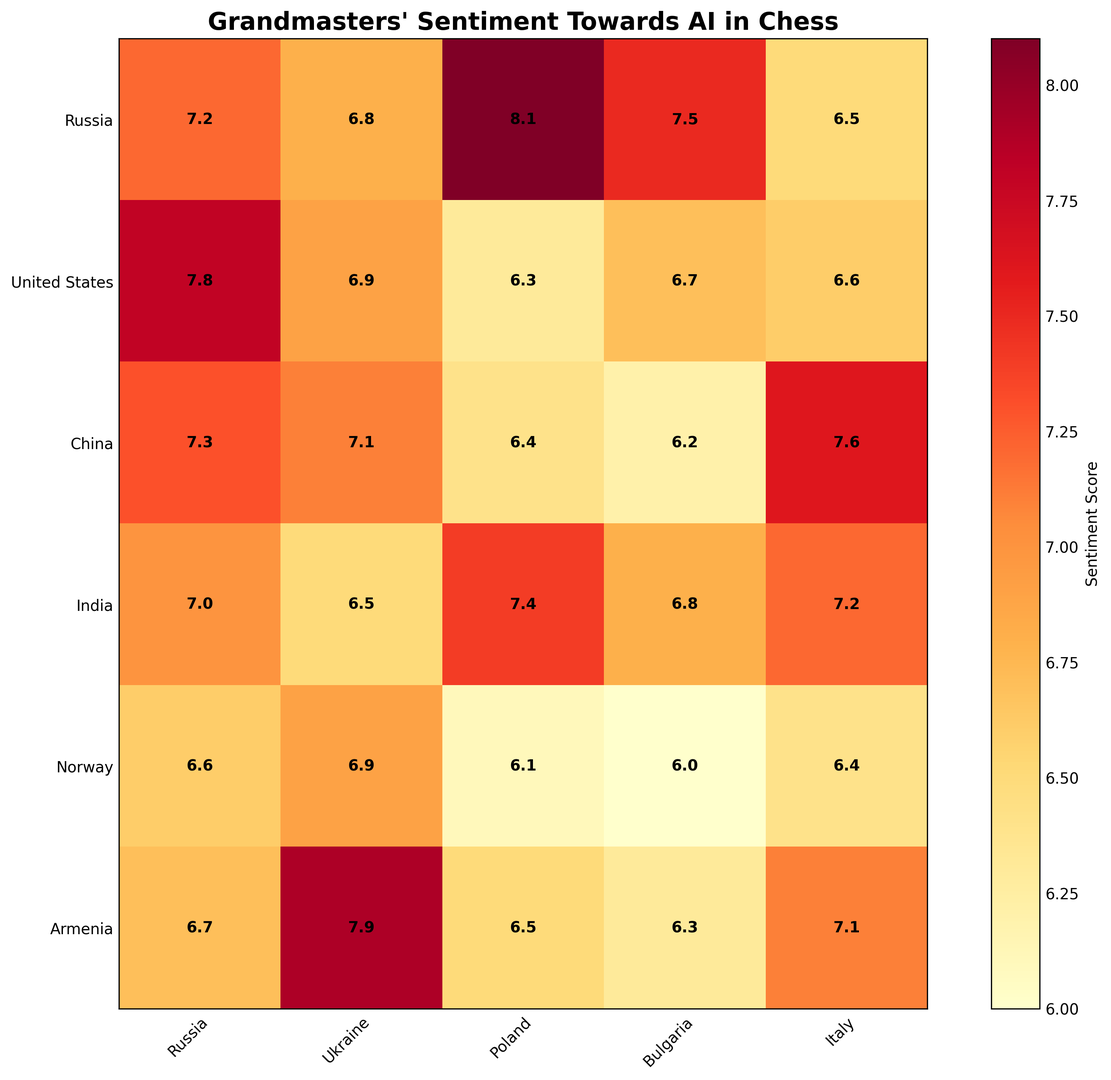Which country shows the highest sentiment score towards AI? The sentiment scores are represented by various shades of colors. The highest sentiment score will be the darkest or most intense color, corresponding to the highest numerical value
Answer: China Which two countries have the lowest sentiment scores towards AI? Look for the least intense colors in the matrix, corresponding to the lowest numerical values. The two countries with the lowest sentiment scores are Denmark and Sweden
Answer: Denmark and Sweden What is the average sentiment score of the countries in the top row? The scores in the top row are 7.2 (Russia), 6.8 (United States), 8.1 (China), 7.5 (India), and 6.5 (Norway). Sum these values and divide by 5: (7.2 + 6.8 + 8.1 + 7.5 + 6.5) / 5 = 36.1 / 5
Answer: 7.22 Is there a significant difference between the sentiment scores of European and non-European countries? Identify the European countries (e.g., Russia, Germany, France) and non-European countries (e.g., United States, China, India). Summarize their sentiment scores and compare the two groups' averages. Europe: (7.2 + 6.7 + 6.3 + 6.6 + 6.4 + 6.1 + 6.0 + 6.4 + 6.2 + 7.2 + 6.6 + 6.9 + 6.1) = 83.7 / 13 = ~6.44. Non-Europe: (6.8 + 8.1 + 7.5 + 7.6 + 7.9 + 6.5) = 44.4 / 6 = ~7.4. There's a noticeable difference with non-European countries generally having higher scores
Answer: Yes How many countries have sentiment scores greater than 7? Identify countries with scores strictly greater than 7: Russia (7.2), China (8.1), India (7.5), Armenia (7.8), Hungary (7.3), Japan (7.9), etc. Count these countries from the matrix
Answer: 11 